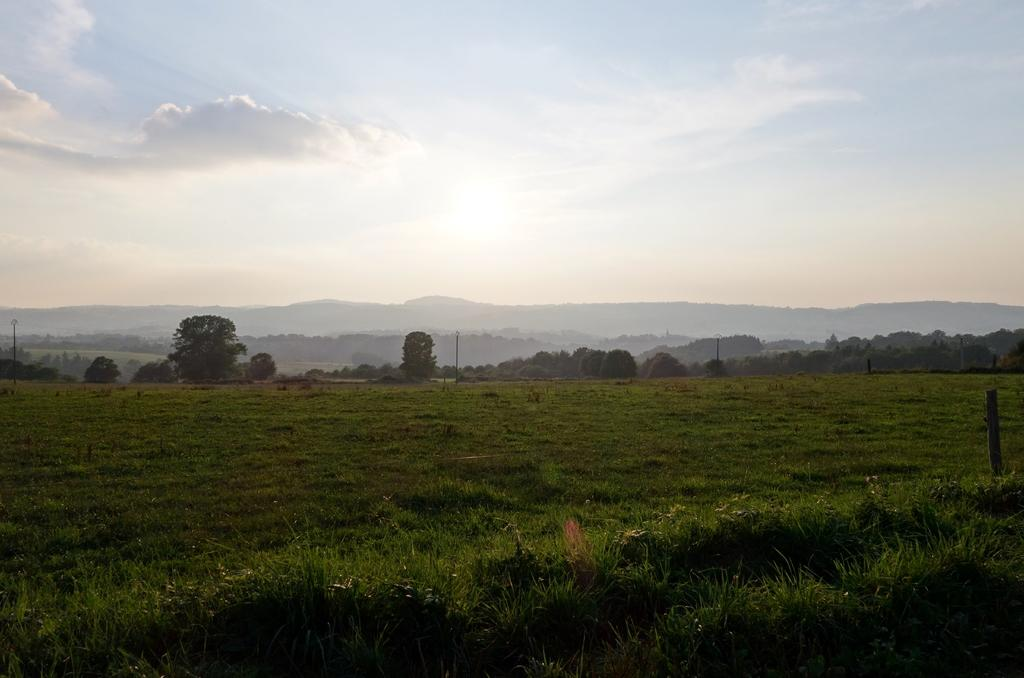What type of vegetation can be seen in the image? There are trees and grass in the image. What structures are present in the image? There are poles in the image. What type of terrain is visible in the image? There are hills in the image. What is visible in the background of the image? The sky is visible in the background of the image. What team is playing on the slope in the image? There is no team or slope present in the image. What does the grass smell like in the image? The image does not provide information about the smell of the grass. 